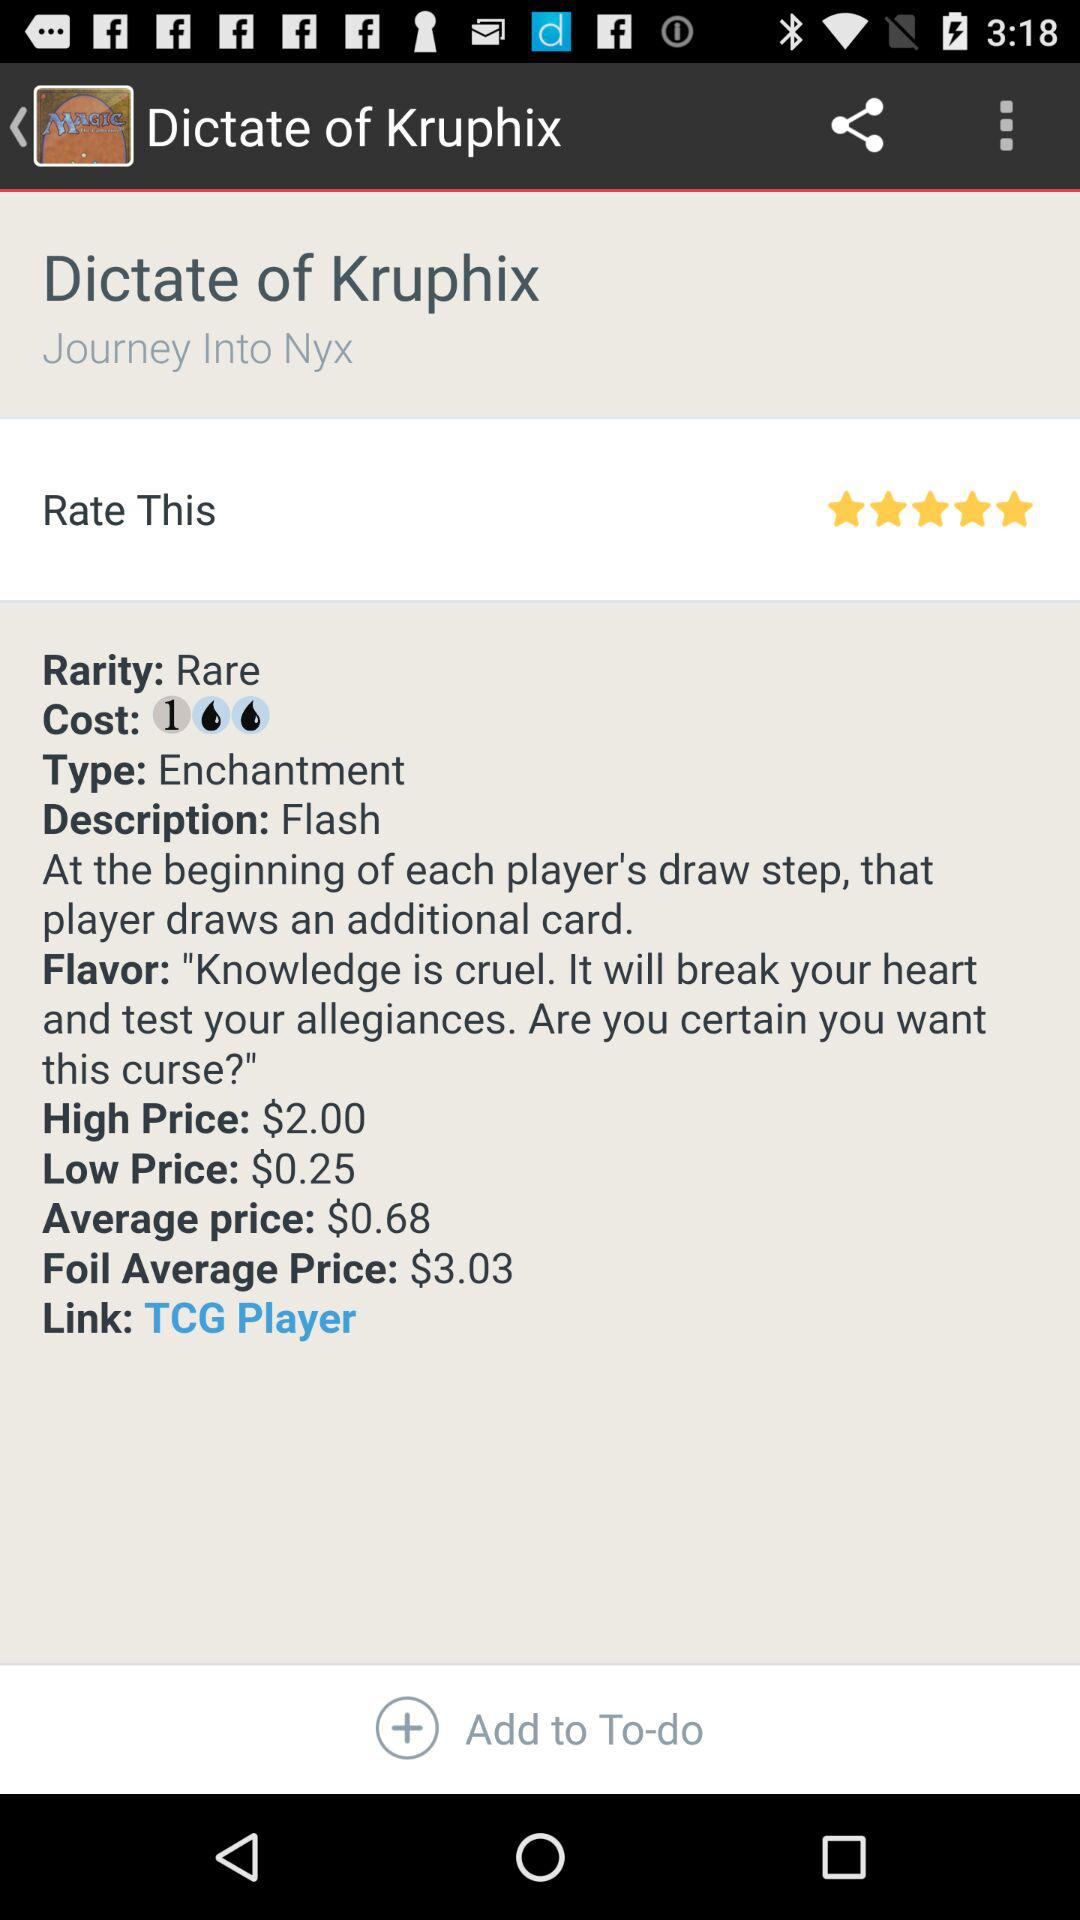How much more does the high price cost than the low price?
Answer the question using a single word or phrase. $1.75 